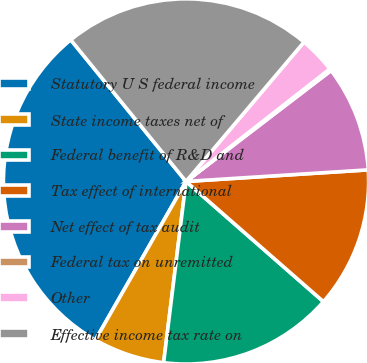<chart> <loc_0><loc_0><loc_500><loc_500><pie_chart><fcel>Statutory U S federal income<fcel>State income taxes net of<fcel>Federal benefit of R&D and<fcel>Tax effect of international<fcel>Net effect of tax audit<fcel>Federal tax on unremitted<fcel>Other<fcel>Effective income tax rate on<nl><fcel>30.86%<fcel>6.31%<fcel>15.52%<fcel>12.45%<fcel>9.38%<fcel>0.18%<fcel>3.25%<fcel>22.05%<nl></chart> 